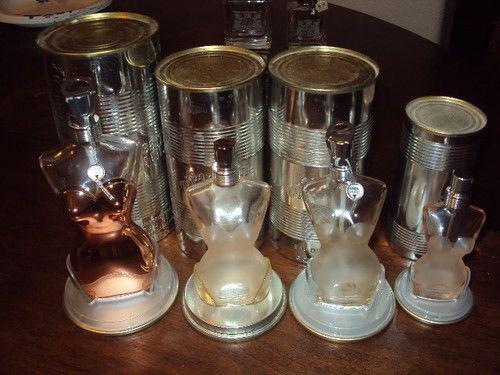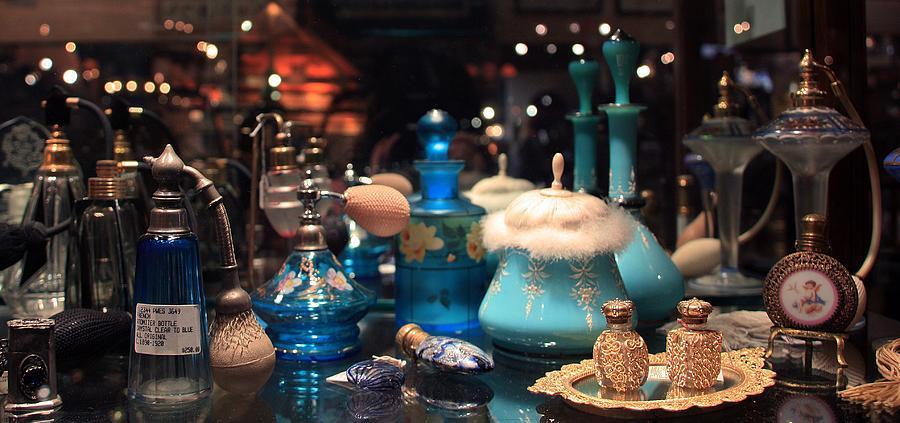The first image is the image on the left, the second image is the image on the right. Examine the images to the left and right. Is the description "A website address is visible in both images." accurate? Answer yes or no. No. The first image is the image on the left, the second image is the image on the right. Considering the images on both sides, is "One of the images contains a bottle of perfume that is shaped like a woman's figure." valid? Answer yes or no. Yes. 